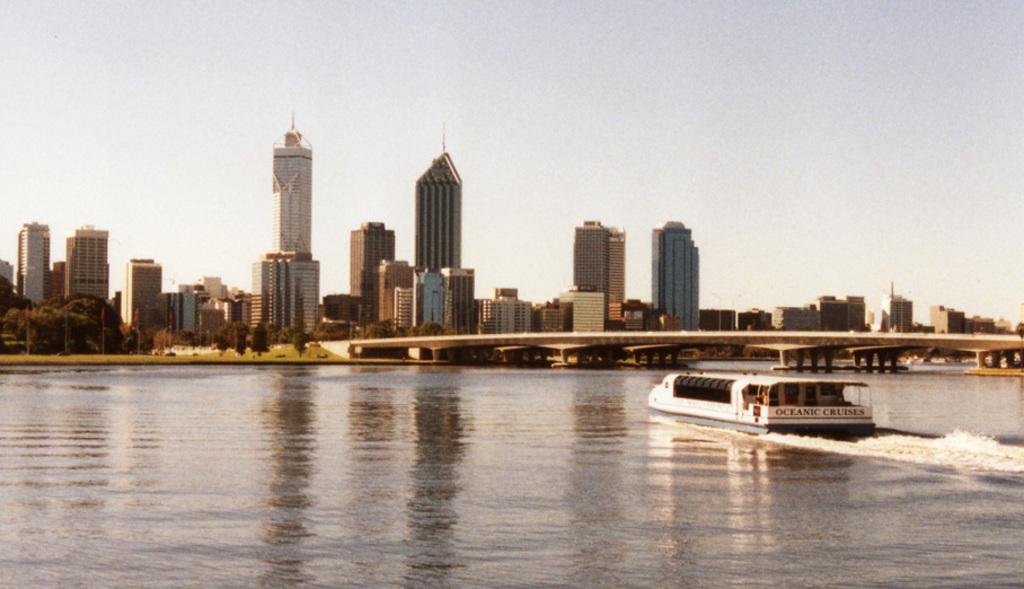What is the main subject of the image? The main subject of the image is a ship. Can you describe the appearance of the ship? The ship is white and black in color. Where is the ship located in the image? The ship is in the water. What can be seen in the background of the image? In the background of the image, there is a bridge, trees, buildings, and the sky. What type of sign can be seen on the ship in the image? There is no sign visible on the ship in the image. How does the daughter feel about the ship in the image? There is no information about a daughter or her feelings in the image. 